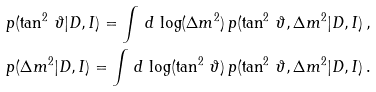Convert formula to latex. <formula><loc_0><loc_0><loc_500><loc_500>\null & \null p ( \tan ^ { 2 } \, \vartheta | D , I ) = \int \, d \, \log ( \Delta { m } ^ { 2 } ) \, p ( \tan ^ { 2 } \, \vartheta , \Delta { m } ^ { 2 } | D , I ) \, , \\ \null & \null p ( \Delta { m } ^ { 2 } | D , I ) = \int \, d \, \log ( \tan ^ { 2 } \, \vartheta ) \, p ( \tan ^ { 2 } \, \vartheta , \Delta { m } ^ { 2 } | D , I ) \, .</formula> 